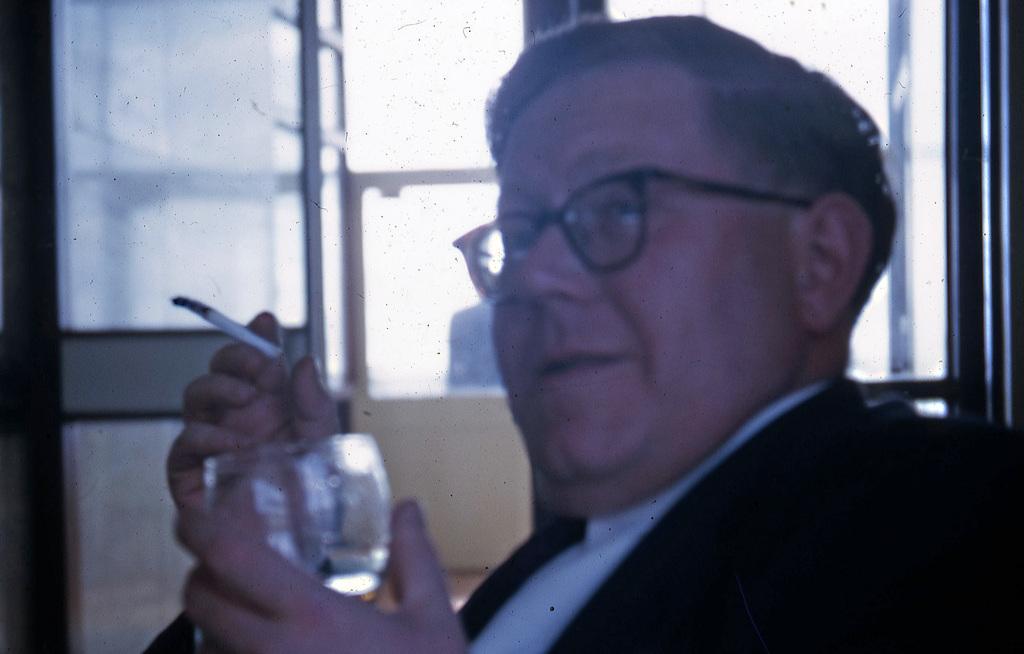In one or two sentences, can you explain what this image depicts? In the picture we can see a man sitting and holding the glass and in other hand, we can see the cigarette and he is in a black blazer, and behind him we can see the window with glass to it. 